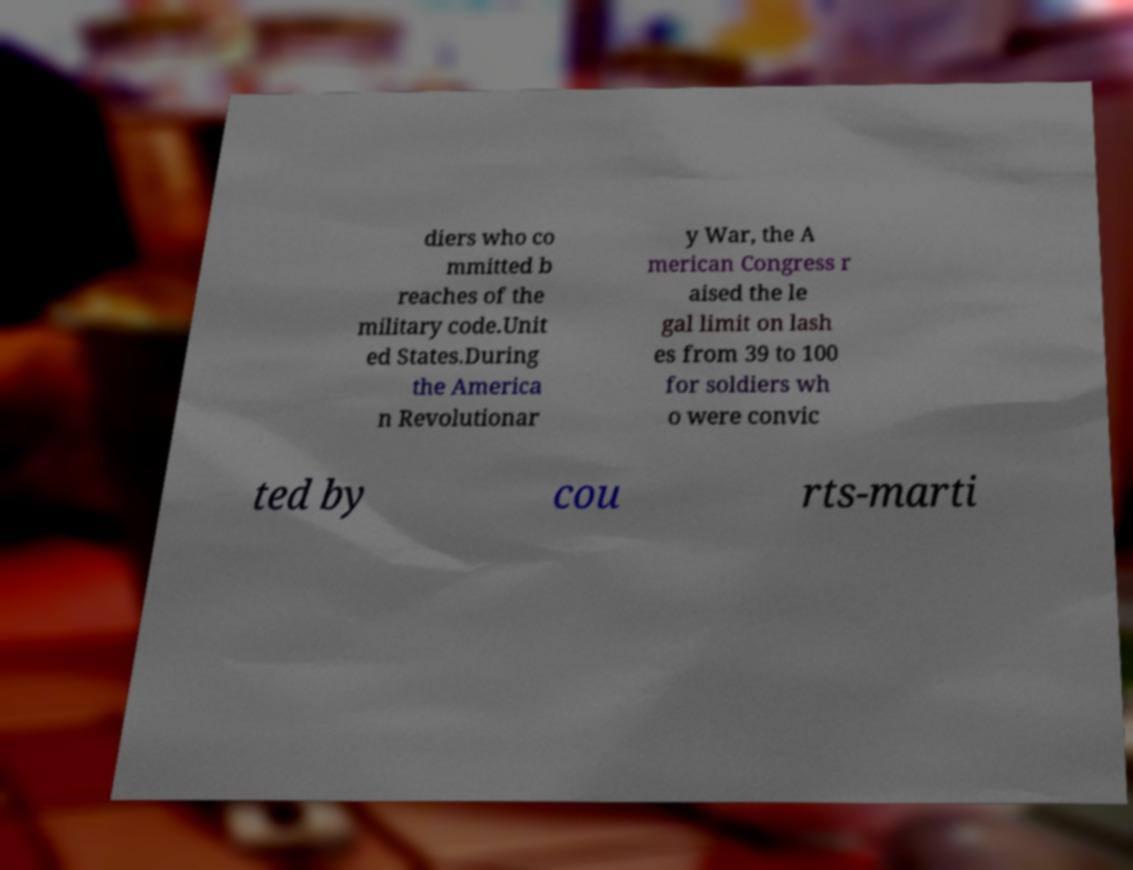What messages or text are displayed in this image? I need them in a readable, typed format. diers who co mmitted b reaches of the military code.Unit ed States.During the America n Revolutionar y War, the A merican Congress r aised the le gal limit on lash es from 39 to 100 for soldiers wh o were convic ted by cou rts-marti 